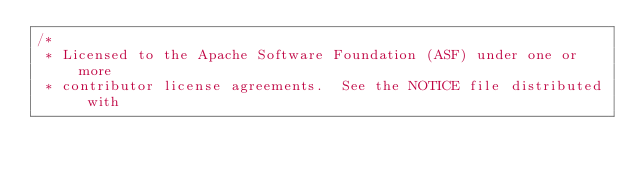<code> <loc_0><loc_0><loc_500><loc_500><_Scala_>/*
 * Licensed to the Apache Software Foundation (ASF) under one or more
 * contributor license agreements.  See the NOTICE file distributed with</code> 